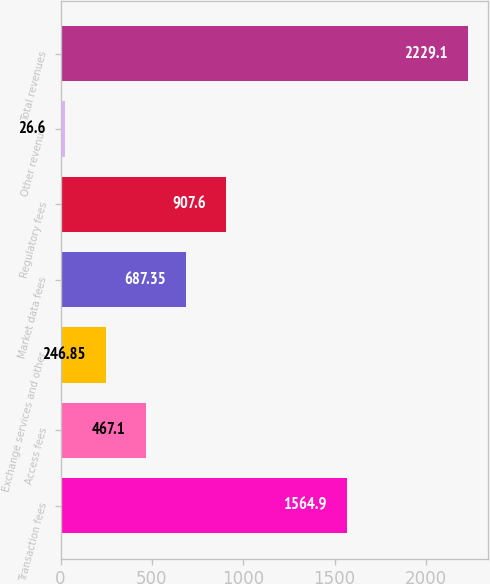Convert chart. <chart><loc_0><loc_0><loc_500><loc_500><bar_chart><fcel>Transaction fees<fcel>Access fees<fcel>Exchange services and other<fcel>Market data fees<fcel>Regulatory fees<fcel>Other revenue<fcel>Total revenues<nl><fcel>1564.9<fcel>467.1<fcel>246.85<fcel>687.35<fcel>907.6<fcel>26.6<fcel>2229.1<nl></chart> 